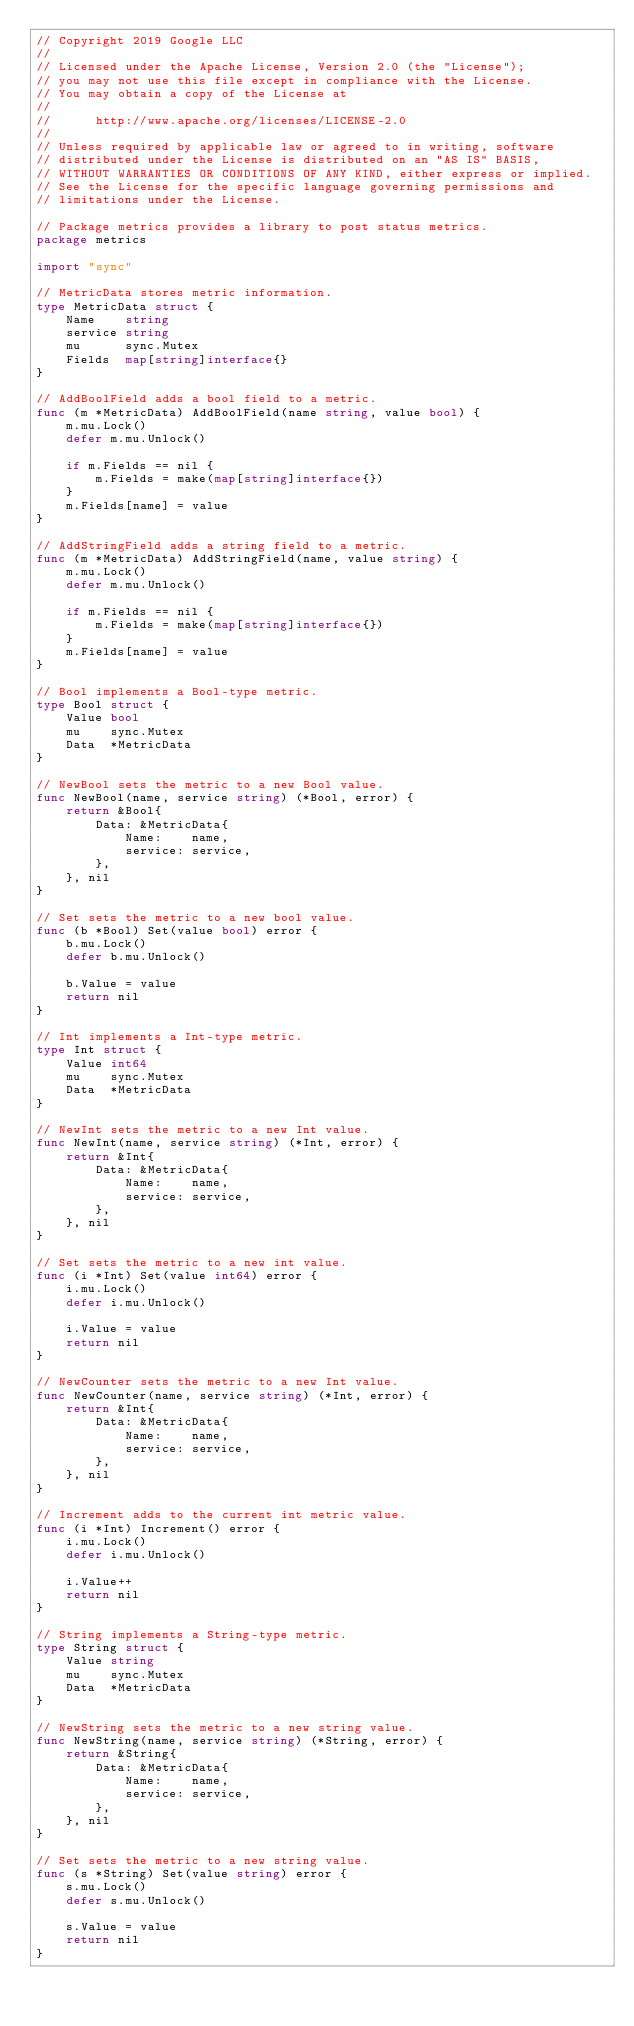<code> <loc_0><loc_0><loc_500><loc_500><_Go_>// Copyright 2019 Google LLC
//
// Licensed under the Apache License, Version 2.0 (the "License");
// you may not use this file except in compliance with the License.
// You may obtain a copy of the License at
//
//      http://www.apache.org/licenses/LICENSE-2.0
//
// Unless required by applicable law or agreed to in writing, software
// distributed under the License is distributed on an "AS IS" BASIS,
// WITHOUT WARRANTIES OR CONDITIONS OF ANY KIND, either express or implied.
// See the License for the specific language governing permissions and
// limitations under the License.

// Package metrics provides a library to post status metrics.
package metrics

import "sync"

// MetricData stores metric information.
type MetricData struct {
	Name    string
	service string
	mu      sync.Mutex
	Fields  map[string]interface{}
}

// AddBoolField adds a bool field to a metric.
func (m *MetricData) AddBoolField(name string, value bool) {
	m.mu.Lock()
	defer m.mu.Unlock()

	if m.Fields == nil {
		m.Fields = make(map[string]interface{})
	}
	m.Fields[name] = value
}

// AddStringField adds a string field to a metric.
func (m *MetricData) AddStringField(name, value string) {
	m.mu.Lock()
	defer m.mu.Unlock()

	if m.Fields == nil {
		m.Fields = make(map[string]interface{})
	}
	m.Fields[name] = value
}

// Bool implements a Bool-type metric.
type Bool struct {
	Value bool
	mu    sync.Mutex
	Data  *MetricData
}

// NewBool sets the metric to a new Bool value.
func NewBool(name, service string) (*Bool, error) {
	return &Bool{
		Data: &MetricData{
			Name:    name,
			service: service,
		},
	}, nil
}

// Set sets the metric to a new bool value.
func (b *Bool) Set(value bool) error {
	b.mu.Lock()
	defer b.mu.Unlock()

	b.Value = value
	return nil
}

// Int implements a Int-type metric.
type Int struct {
	Value int64
	mu    sync.Mutex
	Data  *MetricData
}

// NewInt sets the metric to a new Int value.
func NewInt(name, service string) (*Int, error) {
	return &Int{
		Data: &MetricData{
			Name:    name,
			service: service,
		},
	}, nil
}

// Set sets the metric to a new int value.
func (i *Int) Set(value int64) error {
	i.mu.Lock()
	defer i.mu.Unlock()

	i.Value = value
	return nil
}

// NewCounter sets the metric to a new Int value.
func NewCounter(name, service string) (*Int, error) {
	return &Int{
		Data: &MetricData{
			Name:    name,
			service: service,
		},
	}, nil
}

// Increment adds to the current int metric value.
func (i *Int) Increment() error {
	i.mu.Lock()
	defer i.mu.Unlock()

	i.Value++
	return nil
}

// String implements a String-type metric.
type String struct {
	Value string
	mu    sync.Mutex
	Data  *MetricData
}

// NewString sets the metric to a new string value.
func NewString(name, service string) (*String, error) {
	return &String{
		Data: &MetricData{
			Name:    name,
			service: service,
		},
	}, nil
}

// Set sets the metric to a new string value.
func (s *String) Set(value string) error {
	s.mu.Lock()
	defer s.mu.Unlock()

	s.Value = value
	return nil
}
</code> 